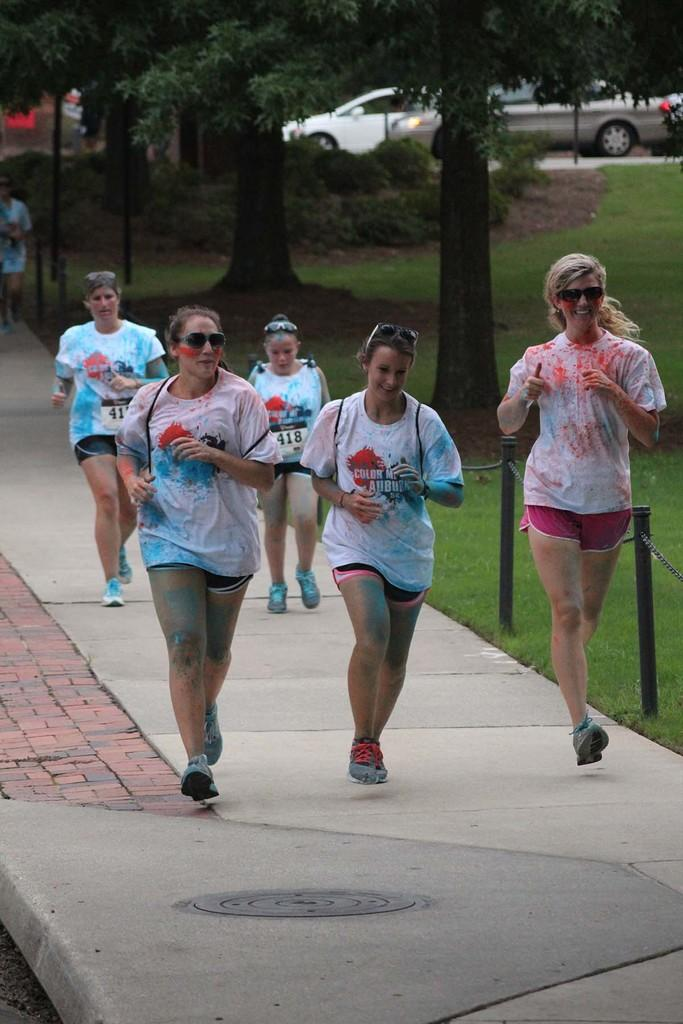What can be seen in the foreground of the image? There are people in the foreground of the image. What type of vegetation is present in the image? There are trees in the image. What else can be seen in the image besides people and trees? There are vehicles and grassland in the image. Can you describe the background of the image? There is a person in the background of the image. What type of butter is being used by the person in the background of the image? There is no butter present in the image, and therefore no such activity can be observed. What type of pleasure is being experienced by the people in the foreground of the image? The image does not provide information about the emotions or experiences of the people, so it cannot be determined what type of pleasure they might be experiencing. 